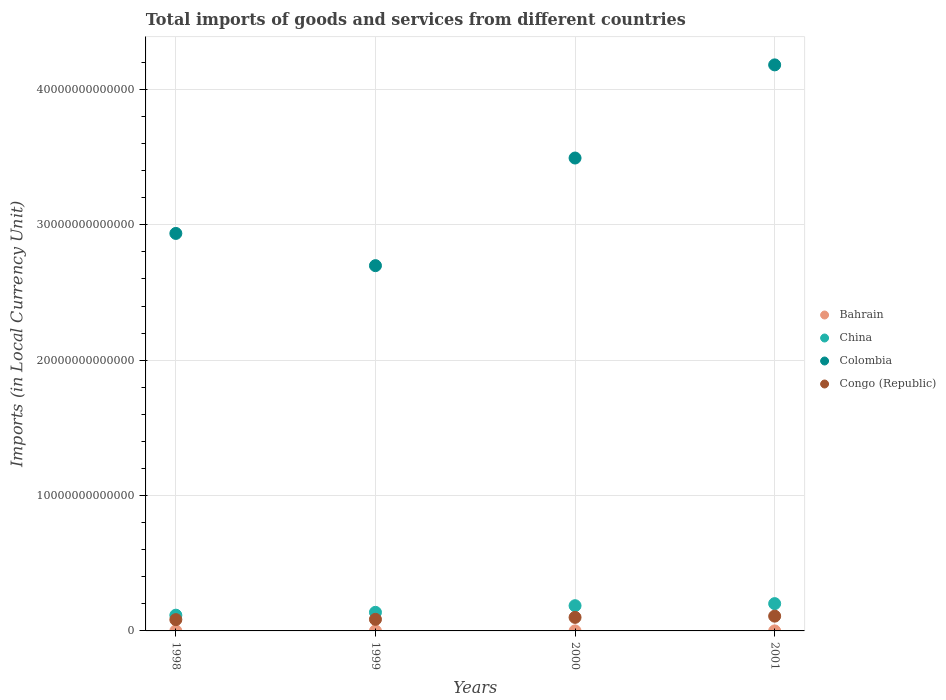What is the Amount of goods and services imports in Colombia in 2001?
Your answer should be very brief. 4.18e+13. Across all years, what is the maximum Amount of goods and services imports in Colombia?
Keep it short and to the point. 4.18e+13. Across all years, what is the minimum Amount of goods and services imports in China?
Make the answer very short. 1.16e+12. What is the total Amount of goods and services imports in Congo (Republic) in the graph?
Offer a very short reply. 3.78e+12. What is the difference between the Amount of goods and services imports in Bahrain in 1999 and that in 2000?
Provide a short and direct response. -3.62e+08. What is the difference between the Amount of goods and services imports in Bahrain in 1999 and the Amount of goods and services imports in China in 2001?
Offer a very short reply. -2.01e+12. What is the average Amount of goods and services imports in Colombia per year?
Ensure brevity in your answer.  3.33e+13. In the year 1998, what is the difference between the Amount of goods and services imports in Colombia and Amount of goods and services imports in Congo (Republic)?
Your answer should be compact. 2.85e+13. What is the ratio of the Amount of goods and services imports in Colombia in 1998 to that in 2000?
Your answer should be very brief. 0.84. Is the Amount of goods and services imports in Congo (Republic) in 2000 less than that in 2001?
Your answer should be compact. Yes. Is the difference between the Amount of goods and services imports in Colombia in 1999 and 2001 greater than the difference between the Amount of goods and services imports in Congo (Republic) in 1999 and 2001?
Give a very brief answer. No. What is the difference between the highest and the second highest Amount of goods and services imports in China?
Your response must be concise. 1.52e+11. What is the difference between the highest and the lowest Amount of goods and services imports in Bahrain?
Give a very brief answer. 4.44e+08. Is the sum of the Amount of goods and services imports in Congo (Republic) in 1998 and 1999 greater than the maximum Amount of goods and services imports in Bahrain across all years?
Provide a short and direct response. Yes. Is the Amount of goods and services imports in Congo (Republic) strictly greater than the Amount of goods and services imports in Bahrain over the years?
Your response must be concise. Yes. What is the difference between two consecutive major ticks on the Y-axis?
Give a very brief answer. 1.00e+13. How are the legend labels stacked?
Make the answer very short. Vertical. What is the title of the graph?
Offer a terse response. Total imports of goods and services from different countries. Does "Sint Maarten (Dutch part)" appear as one of the legend labels in the graph?
Provide a short and direct response. No. What is the label or title of the X-axis?
Provide a succinct answer. Years. What is the label or title of the Y-axis?
Provide a succinct answer. Imports (in Local Currency Unit). What is the Imports (in Local Currency Unit) in Bahrain in 1998?
Offer a terse response. 1.49e+09. What is the Imports (in Local Currency Unit) of China in 1998?
Offer a terse response. 1.16e+12. What is the Imports (in Local Currency Unit) in Colombia in 1998?
Make the answer very short. 2.94e+13. What is the Imports (in Local Currency Unit) in Congo (Republic) in 1998?
Your answer should be compact. 8.35e+11. What is the Imports (in Local Currency Unit) in Bahrain in 1999?
Keep it short and to the point. 1.57e+09. What is the Imports (in Local Currency Unit) of China in 1999?
Provide a succinct answer. 1.37e+12. What is the Imports (in Local Currency Unit) of Colombia in 1999?
Provide a succinct answer. 2.70e+13. What is the Imports (in Local Currency Unit) of Congo (Republic) in 1999?
Your answer should be very brief. 8.57e+11. What is the Imports (in Local Currency Unit) in Bahrain in 2000?
Offer a terse response. 1.93e+09. What is the Imports (in Local Currency Unit) of China in 2000?
Keep it short and to the point. 1.86e+12. What is the Imports (in Local Currency Unit) of Colombia in 2000?
Your answer should be compact. 3.49e+13. What is the Imports (in Local Currency Unit) in Congo (Republic) in 2000?
Your answer should be very brief. 1.00e+12. What is the Imports (in Local Currency Unit) of Bahrain in 2001?
Your response must be concise. 1.80e+09. What is the Imports (in Local Currency Unit) in China in 2001?
Provide a short and direct response. 2.02e+12. What is the Imports (in Local Currency Unit) in Colombia in 2001?
Your answer should be very brief. 4.18e+13. What is the Imports (in Local Currency Unit) in Congo (Republic) in 2001?
Offer a terse response. 1.09e+12. Across all years, what is the maximum Imports (in Local Currency Unit) of Bahrain?
Provide a short and direct response. 1.93e+09. Across all years, what is the maximum Imports (in Local Currency Unit) of China?
Your answer should be very brief. 2.02e+12. Across all years, what is the maximum Imports (in Local Currency Unit) of Colombia?
Your response must be concise. 4.18e+13. Across all years, what is the maximum Imports (in Local Currency Unit) in Congo (Republic)?
Provide a short and direct response. 1.09e+12. Across all years, what is the minimum Imports (in Local Currency Unit) of Bahrain?
Offer a terse response. 1.49e+09. Across all years, what is the minimum Imports (in Local Currency Unit) in China?
Provide a short and direct response. 1.16e+12. Across all years, what is the minimum Imports (in Local Currency Unit) of Colombia?
Give a very brief answer. 2.70e+13. Across all years, what is the minimum Imports (in Local Currency Unit) in Congo (Republic)?
Your answer should be compact. 8.35e+11. What is the total Imports (in Local Currency Unit) in Bahrain in the graph?
Your response must be concise. 6.79e+09. What is the total Imports (in Local Currency Unit) of China in the graph?
Your answer should be very brief. 6.42e+12. What is the total Imports (in Local Currency Unit) in Colombia in the graph?
Your answer should be compact. 1.33e+14. What is the total Imports (in Local Currency Unit) in Congo (Republic) in the graph?
Your answer should be compact. 3.78e+12. What is the difference between the Imports (in Local Currency Unit) of Bahrain in 1998 and that in 1999?
Ensure brevity in your answer.  -8.21e+07. What is the difference between the Imports (in Local Currency Unit) of China in 1998 and that in 1999?
Ensure brevity in your answer.  -2.11e+11. What is the difference between the Imports (in Local Currency Unit) in Colombia in 1998 and that in 1999?
Your response must be concise. 2.38e+12. What is the difference between the Imports (in Local Currency Unit) in Congo (Republic) in 1998 and that in 1999?
Your answer should be compact. -2.13e+1. What is the difference between the Imports (in Local Currency Unit) in Bahrain in 1998 and that in 2000?
Your response must be concise. -4.44e+08. What is the difference between the Imports (in Local Currency Unit) of China in 1998 and that in 2000?
Provide a short and direct response. -7.01e+11. What is the difference between the Imports (in Local Currency Unit) of Colombia in 1998 and that in 2000?
Provide a short and direct response. -5.57e+12. What is the difference between the Imports (in Local Currency Unit) of Congo (Republic) in 1998 and that in 2000?
Your answer should be very brief. -1.65e+11. What is the difference between the Imports (in Local Currency Unit) of Bahrain in 1998 and that in 2001?
Make the answer very short. -3.17e+08. What is the difference between the Imports (in Local Currency Unit) of China in 1998 and that in 2001?
Offer a very short reply. -8.53e+11. What is the difference between the Imports (in Local Currency Unit) of Colombia in 1998 and that in 2001?
Make the answer very short. -1.25e+13. What is the difference between the Imports (in Local Currency Unit) in Congo (Republic) in 1998 and that in 2001?
Your answer should be compact. -2.57e+11. What is the difference between the Imports (in Local Currency Unit) in Bahrain in 1999 and that in 2000?
Provide a short and direct response. -3.62e+08. What is the difference between the Imports (in Local Currency Unit) in China in 1999 and that in 2000?
Your answer should be very brief. -4.90e+11. What is the difference between the Imports (in Local Currency Unit) in Colombia in 1999 and that in 2000?
Your answer should be compact. -7.95e+12. What is the difference between the Imports (in Local Currency Unit) in Congo (Republic) in 1999 and that in 2000?
Your response must be concise. -1.43e+11. What is the difference between the Imports (in Local Currency Unit) in Bahrain in 1999 and that in 2001?
Your answer should be compact. -2.35e+08. What is the difference between the Imports (in Local Currency Unit) of China in 1999 and that in 2001?
Ensure brevity in your answer.  -6.42e+11. What is the difference between the Imports (in Local Currency Unit) of Colombia in 1999 and that in 2001?
Ensure brevity in your answer.  -1.48e+13. What is the difference between the Imports (in Local Currency Unit) in Congo (Republic) in 1999 and that in 2001?
Your answer should be very brief. -2.35e+11. What is the difference between the Imports (in Local Currency Unit) of Bahrain in 2000 and that in 2001?
Give a very brief answer. 1.27e+08. What is the difference between the Imports (in Local Currency Unit) of China in 2000 and that in 2001?
Ensure brevity in your answer.  -1.52e+11. What is the difference between the Imports (in Local Currency Unit) in Colombia in 2000 and that in 2001?
Keep it short and to the point. -6.88e+12. What is the difference between the Imports (in Local Currency Unit) in Congo (Republic) in 2000 and that in 2001?
Provide a short and direct response. -9.22e+1. What is the difference between the Imports (in Local Currency Unit) of Bahrain in 1998 and the Imports (in Local Currency Unit) of China in 1999?
Your response must be concise. -1.37e+12. What is the difference between the Imports (in Local Currency Unit) of Bahrain in 1998 and the Imports (in Local Currency Unit) of Colombia in 1999?
Give a very brief answer. -2.70e+13. What is the difference between the Imports (in Local Currency Unit) of Bahrain in 1998 and the Imports (in Local Currency Unit) of Congo (Republic) in 1999?
Make the answer very short. -8.55e+11. What is the difference between the Imports (in Local Currency Unit) of China in 1998 and the Imports (in Local Currency Unit) of Colombia in 1999?
Your answer should be very brief. -2.58e+13. What is the difference between the Imports (in Local Currency Unit) in China in 1998 and the Imports (in Local Currency Unit) in Congo (Republic) in 1999?
Your answer should be compact. 3.06e+11. What is the difference between the Imports (in Local Currency Unit) in Colombia in 1998 and the Imports (in Local Currency Unit) in Congo (Republic) in 1999?
Make the answer very short. 2.85e+13. What is the difference between the Imports (in Local Currency Unit) in Bahrain in 1998 and the Imports (in Local Currency Unit) in China in 2000?
Provide a succinct answer. -1.86e+12. What is the difference between the Imports (in Local Currency Unit) in Bahrain in 1998 and the Imports (in Local Currency Unit) in Colombia in 2000?
Ensure brevity in your answer.  -3.49e+13. What is the difference between the Imports (in Local Currency Unit) of Bahrain in 1998 and the Imports (in Local Currency Unit) of Congo (Republic) in 2000?
Provide a succinct answer. -9.98e+11. What is the difference between the Imports (in Local Currency Unit) of China in 1998 and the Imports (in Local Currency Unit) of Colombia in 2000?
Make the answer very short. -3.38e+13. What is the difference between the Imports (in Local Currency Unit) of China in 1998 and the Imports (in Local Currency Unit) of Congo (Republic) in 2000?
Offer a very short reply. 1.63e+11. What is the difference between the Imports (in Local Currency Unit) of Colombia in 1998 and the Imports (in Local Currency Unit) of Congo (Republic) in 2000?
Your answer should be compact. 2.84e+13. What is the difference between the Imports (in Local Currency Unit) in Bahrain in 1998 and the Imports (in Local Currency Unit) in China in 2001?
Provide a succinct answer. -2.01e+12. What is the difference between the Imports (in Local Currency Unit) in Bahrain in 1998 and the Imports (in Local Currency Unit) in Colombia in 2001?
Make the answer very short. -4.18e+13. What is the difference between the Imports (in Local Currency Unit) in Bahrain in 1998 and the Imports (in Local Currency Unit) in Congo (Republic) in 2001?
Keep it short and to the point. -1.09e+12. What is the difference between the Imports (in Local Currency Unit) of China in 1998 and the Imports (in Local Currency Unit) of Colombia in 2001?
Provide a succinct answer. -4.07e+13. What is the difference between the Imports (in Local Currency Unit) of China in 1998 and the Imports (in Local Currency Unit) of Congo (Republic) in 2001?
Ensure brevity in your answer.  7.06e+1. What is the difference between the Imports (in Local Currency Unit) in Colombia in 1998 and the Imports (in Local Currency Unit) in Congo (Republic) in 2001?
Your answer should be compact. 2.83e+13. What is the difference between the Imports (in Local Currency Unit) of Bahrain in 1999 and the Imports (in Local Currency Unit) of China in 2000?
Provide a succinct answer. -1.86e+12. What is the difference between the Imports (in Local Currency Unit) in Bahrain in 1999 and the Imports (in Local Currency Unit) in Colombia in 2000?
Ensure brevity in your answer.  -3.49e+13. What is the difference between the Imports (in Local Currency Unit) of Bahrain in 1999 and the Imports (in Local Currency Unit) of Congo (Republic) in 2000?
Your answer should be very brief. -9.98e+11. What is the difference between the Imports (in Local Currency Unit) in China in 1999 and the Imports (in Local Currency Unit) in Colombia in 2000?
Ensure brevity in your answer.  -3.36e+13. What is the difference between the Imports (in Local Currency Unit) in China in 1999 and the Imports (in Local Currency Unit) in Congo (Republic) in 2000?
Offer a very short reply. 3.74e+11. What is the difference between the Imports (in Local Currency Unit) in Colombia in 1999 and the Imports (in Local Currency Unit) in Congo (Republic) in 2000?
Your answer should be compact. 2.60e+13. What is the difference between the Imports (in Local Currency Unit) of Bahrain in 1999 and the Imports (in Local Currency Unit) of China in 2001?
Your answer should be compact. -2.01e+12. What is the difference between the Imports (in Local Currency Unit) of Bahrain in 1999 and the Imports (in Local Currency Unit) of Colombia in 2001?
Offer a terse response. -4.18e+13. What is the difference between the Imports (in Local Currency Unit) of Bahrain in 1999 and the Imports (in Local Currency Unit) of Congo (Republic) in 2001?
Your response must be concise. -1.09e+12. What is the difference between the Imports (in Local Currency Unit) of China in 1999 and the Imports (in Local Currency Unit) of Colombia in 2001?
Keep it short and to the point. -4.04e+13. What is the difference between the Imports (in Local Currency Unit) of China in 1999 and the Imports (in Local Currency Unit) of Congo (Republic) in 2001?
Ensure brevity in your answer.  2.82e+11. What is the difference between the Imports (in Local Currency Unit) of Colombia in 1999 and the Imports (in Local Currency Unit) of Congo (Republic) in 2001?
Your answer should be very brief. 2.59e+13. What is the difference between the Imports (in Local Currency Unit) in Bahrain in 2000 and the Imports (in Local Currency Unit) in China in 2001?
Make the answer very short. -2.01e+12. What is the difference between the Imports (in Local Currency Unit) of Bahrain in 2000 and the Imports (in Local Currency Unit) of Colombia in 2001?
Give a very brief answer. -4.18e+13. What is the difference between the Imports (in Local Currency Unit) in Bahrain in 2000 and the Imports (in Local Currency Unit) in Congo (Republic) in 2001?
Your answer should be compact. -1.09e+12. What is the difference between the Imports (in Local Currency Unit) of China in 2000 and the Imports (in Local Currency Unit) of Colombia in 2001?
Your answer should be very brief. -4.00e+13. What is the difference between the Imports (in Local Currency Unit) in China in 2000 and the Imports (in Local Currency Unit) in Congo (Republic) in 2001?
Your answer should be compact. 7.72e+11. What is the difference between the Imports (in Local Currency Unit) in Colombia in 2000 and the Imports (in Local Currency Unit) in Congo (Republic) in 2001?
Keep it short and to the point. 3.38e+13. What is the average Imports (in Local Currency Unit) of Bahrain per year?
Offer a very short reply. 1.70e+09. What is the average Imports (in Local Currency Unit) in China per year?
Your answer should be very brief. 1.60e+12. What is the average Imports (in Local Currency Unit) of Colombia per year?
Offer a very short reply. 3.33e+13. What is the average Imports (in Local Currency Unit) in Congo (Republic) per year?
Offer a very short reply. 9.46e+11. In the year 1998, what is the difference between the Imports (in Local Currency Unit) in Bahrain and Imports (in Local Currency Unit) in China?
Your answer should be compact. -1.16e+12. In the year 1998, what is the difference between the Imports (in Local Currency Unit) in Bahrain and Imports (in Local Currency Unit) in Colombia?
Make the answer very short. -2.94e+13. In the year 1998, what is the difference between the Imports (in Local Currency Unit) of Bahrain and Imports (in Local Currency Unit) of Congo (Republic)?
Provide a succinct answer. -8.34e+11. In the year 1998, what is the difference between the Imports (in Local Currency Unit) of China and Imports (in Local Currency Unit) of Colombia?
Make the answer very short. -2.82e+13. In the year 1998, what is the difference between the Imports (in Local Currency Unit) of China and Imports (in Local Currency Unit) of Congo (Republic)?
Give a very brief answer. 3.27e+11. In the year 1998, what is the difference between the Imports (in Local Currency Unit) in Colombia and Imports (in Local Currency Unit) in Congo (Republic)?
Offer a very short reply. 2.85e+13. In the year 1999, what is the difference between the Imports (in Local Currency Unit) of Bahrain and Imports (in Local Currency Unit) of China?
Ensure brevity in your answer.  -1.37e+12. In the year 1999, what is the difference between the Imports (in Local Currency Unit) of Bahrain and Imports (in Local Currency Unit) of Colombia?
Your answer should be compact. -2.70e+13. In the year 1999, what is the difference between the Imports (in Local Currency Unit) of Bahrain and Imports (in Local Currency Unit) of Congo (Republic)?
Ensure brevity in your answer.  -8.55e+11. In the year 1999, what is the difference between the Imports (in Local Currency Unit) in China and Imports (in Local Currency Unit) in Colombia?
Provide a short and direct response. -2.56e+13. In the year 1999, what is the difference between the Imports (in Local Currency Unit) in China and Imports (in Local Currency Unit) in Congo (Republic)?
Offer a terse response. 5.17e+11. In the year 1999, what is the difference between the Imports (in Local Currency Unit) in Colombia and Imports (in Local Currency Unit) in Congo (Republic)?
Your answer should be compact. 2.61e+13. In the year 2000, what is the difference between the Imports (in Local Currency Unit) of Bahrain and Imports (in Local Currency Unit) of China?
Your answer should be compact. -1.86e+12. In the year 2000, what is the difference between the Imports (in Local Currency Unit) of Bahrain and Imports (in Local Currency Unit) of Colombia?
Make the answer very short. -3.49e+13. In the year 2000, what is the difference between the Imports (in Local Currency Unit) in Bahrain and Imports (in Local Currency Unit) in Congo (Republic)?
Give a very brief answer. -9.98e+11. In the year 2000, what is the difference between the Imports (in Local Currency Unit) in China and Imports (in Local Currency Unit) in Colombia?
Your response must be concise. -3.31e+13. In the year 2000, what is the difference between the Imports (in Local Currency Unit) of China and Imports (in Local Currency Unit) of Congo (Republic)?
Keep it short and to the point. 8.64e+11. In the year 2000, what is the difference between the Imports (in Local Currency Unit) in Colombia and Imports (in Local Currency Unit) in Congo (Republic)?
Keep it short and to the point. 3.39e+13. In the year 2001, what is the difference between the Imports (in Local Currency Unit) of Bahrain and Imports (in Local Currency Unit) of China?
Your answer should be compact. -2.01e+12. In the year 2001, what is the difference between the Imports (in Local Currency Unit) in Bahrain and Imports (in Local Currency Unit) in Colombia?
Your response must be concise. -4.18e+13. In the year 2001, what is the difference between the Imports (in Local Currency Unit) of Bahrain and Imports (in Local Currency Unit) of Congo (Republic)?
Give a very brief answer. -1.09e+12. In the year 2001, what is the difference between the Imports (in Local Currency Unit) in China and Imports (in Local Currency Unit) in Colombia?
Your answer should be very brief. -3.98e+13. In the year 2001, what is the difference between the Imports (in Local Currency Unit) in China and Imports (in Local Currency Unit) in Congo (Republic)?
Your response must be concise. 9.24e+11. In the year 2001, what is the difference between the Imports (in Local Currency Unit) in Colombia and Imports (in Local Currency Unit) in Congo (Republic)?
Make the answer very short. 4.07e+13. What is the ratio of the Imports (in Local Currency Unit) of Bahrain in 1998 to that in 1999?
Offer a terse response. 0.95. What is the ratio of the Imports (in Local Currency Unit) of China in 1998 to that in 1999?
Give a very brief answer. 0.85. What is the ratio of the Imports (in Local Currency Unit) in Colombia in 1998 to that in 1999?
Keep it short and to the point. 1.09. What is the ratio of the Imports (in Local Currency Unit) in Congo (Republic) in 1998 to that in 1999?
Give a very brief answer. 0.98. What is the ratio of the Imports (in Local Currency Unit) of Bahrain in 1998 to that in 2000?
Provide a succinct answer. 0.77. What is the ratio of the Imports (in Local Currency Unit) of China in 1998 to that in 2000?
Provide a short and direct response. 0.62. What is the ratio of the Imports (in Local Currency Unit) in Colombia in 1998 to that in 2000?
Your response must be concise. 0.84. What is the ratio of the Imports (in Local Currency Unit) in Congo (Republic) in 1998 to that in 2000?
Your response must be concise. 0.84. What is the ratio of the Imports (in Local Currency Unit) of Bahrain in 1998 to that in 2001?
Give a very brief answer. 0.82. What is the ratio of the Imports (in Local Currency Unit) of China in 1998 to that in 2001?
Provide a short and direct response. 0.58. What is the ratio of the Imports (in Local Currency Unit) in Colombia in 1998 to that in 2001?
Keep it short and to the point. 0.7. What is the ratio of the Imports (in Local Currency Unit) in Congo (Republic) in 1998 to that in 2001?
Your answer should be very brief. 0.76. What is the ratio of the Imports (in Local Currency Unit) in Bahrain in 1999 to that in 2000?
Provide a succinct answer. 0.81. What is the ratio of the Imports (in Local Currency Unit) of China in 1999 to that in 2000?
Offer a very short reply. 0.74. What is the ratio of the Imports (in Local Currency Unit) in Colombia in 1999 to that in 2000?
Provide a succinct answer. 0.77. What is the ratio of the Imports (in Local Currency Unit) in Congo (Republic) in 1999 to that in 2000?
Offer a terse response. 0.86. What is the ratio of the Imports (in Local Currency Unit) in Bahrain in 1999 to that in 2001?
Your answer should be compact. 0.87. What is the ratio of the Imports (in Local Currency Unit) of China in 1999 to that in 2001?
Your answer should be compact. 0.68. What is the ratio of the Imports (in Local Currency Unit) in Colombia in 1999 to that in 2001?
Your answer should be compact. 0.65. What is the ratio of the Imports (in Local Currency Unit) of Congo (Republic) in 1999 to that in 2001?
Your answer should be very brief. 0.78. What is the ratio of the Imports (in Local Currency Unit) of Bahrain in 2000 to that in 2001?
Make the answer very short. 1.07. What is the ratio of the Imports (in Local Currency Unit) in China in 2000 to that in 2001?
Offer a very short reply. 0.92. What is the ratio of the Imports (in Local Currency Unit) of Colombia in 2000 to that in 2001?
Provide a short and direct response. 0.84. What is the ratio of the Imports (in Local Currency Unit) in Congo (Republic) in 2000 to that in 2001?
Keep it short and to the point. 0.92. What is the difference between the highest and the second highest Imports (in Local Currency Unit) of Bahrain?
Make the answer very short. 1.27e+08. What is the difference between the highest and the second highest Imports (in Local Currency Unit) of China?
Make the answer very short. 1.52e+11. What is the difference between the highest and the second highest Imports (in Local Currency Unit) of Colombia?
Make the answer very short. 6.88e+12. What is the difference between the highest and the second highest Imports (in Local Currency Unit) of Congo (Republic)?
Offer a terse response. 9.22e+1. What is the difference between the highest and the lowest Imports (in Local Currency Unit) of Bahrain?
Your answer should be compact. 4.44e+08. What is the difference between the highest and the lowest Imports (in Local Currency Unit) in China?
Keep it short and to the point. 8.53e+11. What is the difference between the highest and the lowest Imports (in Local Currency Unit) in Colombia?
Your response must be concise. 1.48e+13. What is the difference between the highest and the lowest Imports (in Local Currency Unit) in Congo (Republic)?
Your answer should be very brief. 2.57e+11. 